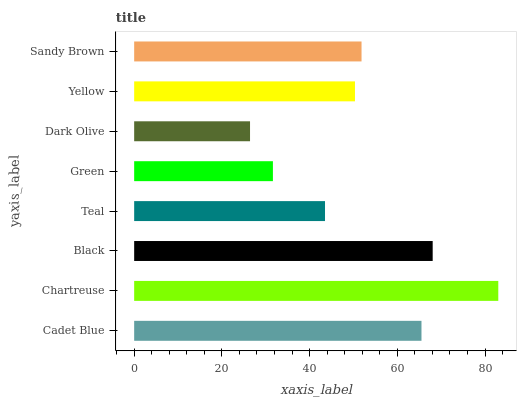Is Dark Olive the minimum?
Answer yes or no. Yes. Is Chartreuse the maximum?
Answer yes or no. Yes. Is Black the minimum?
Answer yes or no. No. Is Black the maximum?
Answer yes or no. No. Is Chartreuse greater than Black?
Answer yes or no. Yes. Is Black less than Chartreuse?
Answer yes or no. Yes. Is Black greater than Chartreuse?
Answer yes or no. No. Is Chartreuse less than Black?
Answer yes or no. No. Is Sandy Brown the high median?
Answer yes or no. Yes. Is Yellow the low median?
Answer yes or no. Yes. Is Black the high median?
Answer yes or no. No. Is Black the low median?
Answer yes or no. No. 